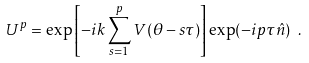<formula> <loc_0><loc_0><loc_500><loc_500>U ^ { p } = \exp \left [ - i k \sum _ { s = 1 } ^ { p } V ( \theta - s \tau ) \right ] \exp ( - i p \tau { \hat { n } } ) \ .</formula> 